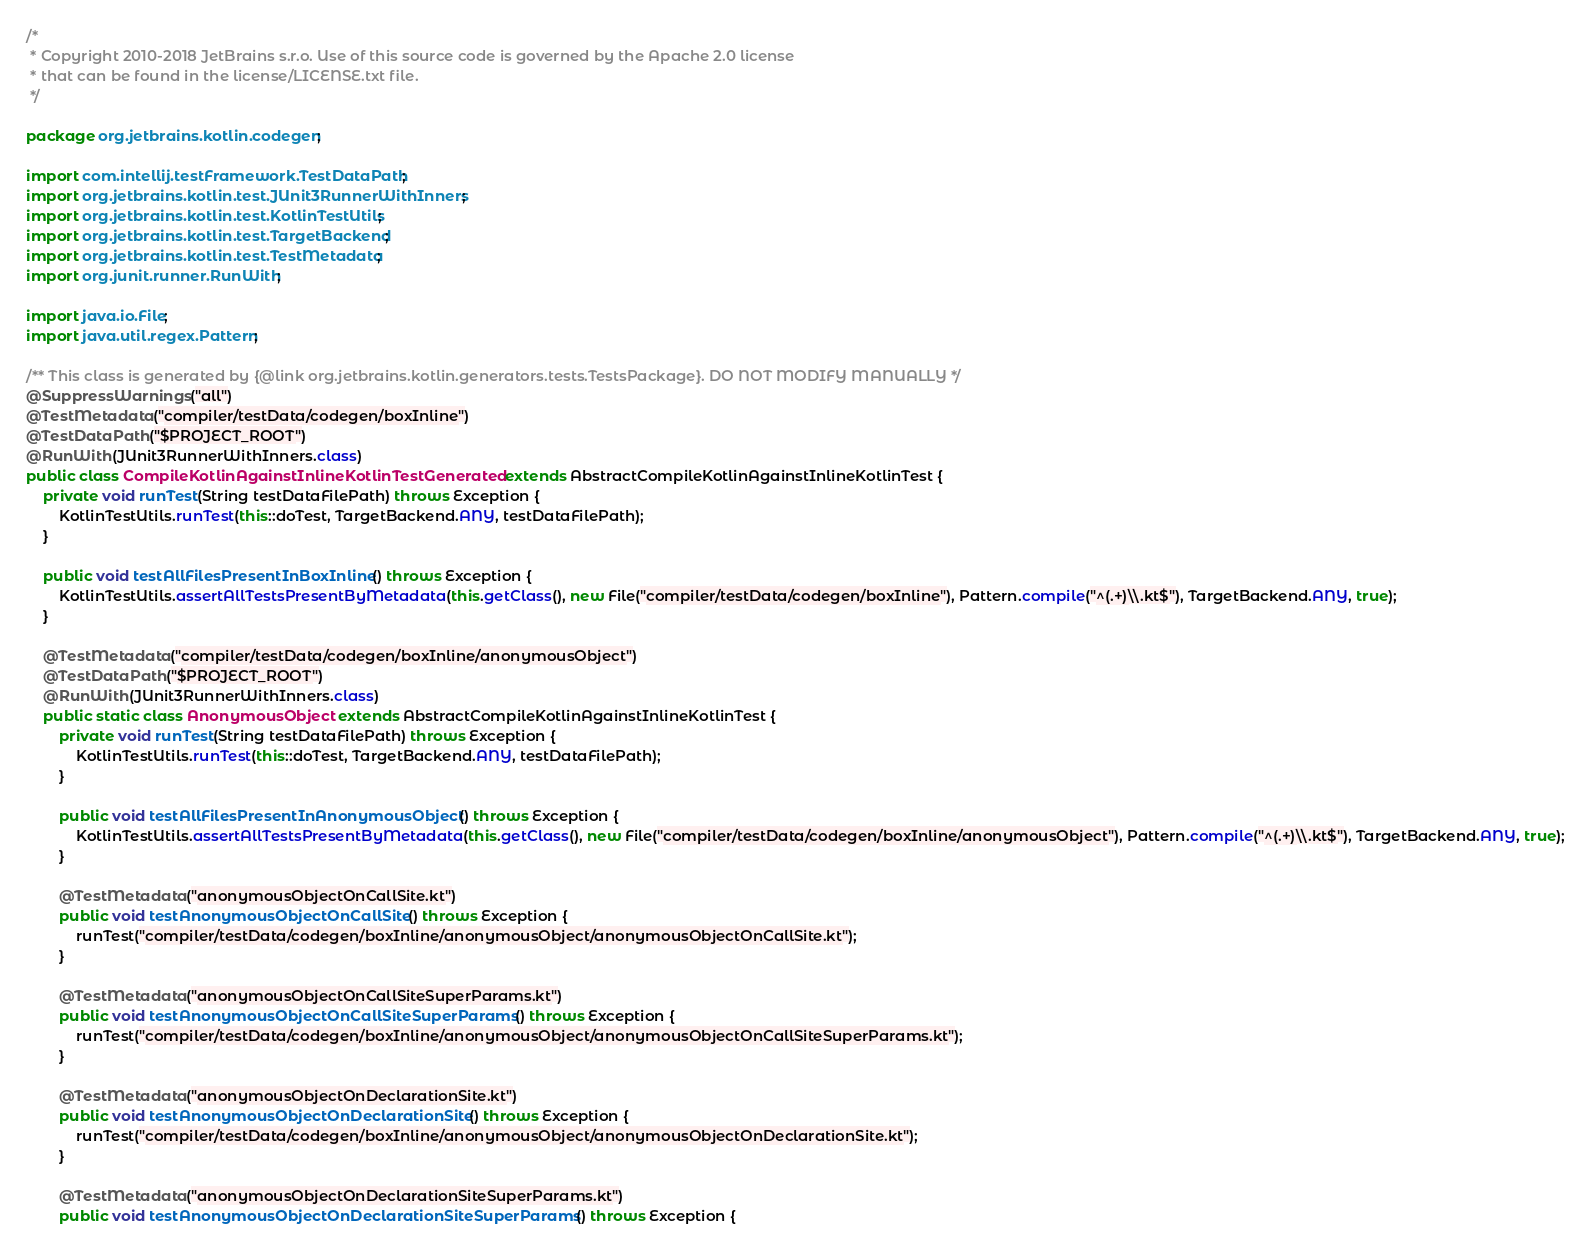Convert code to text. <code><loc_0><loc_0><loc_500><loc_500><_Java_>/*
 * Copyright 2010-2018 JetBrains s.r.o. Use of this source code is governed by the Apache 2.0 license
 * that can be found in the license/LICENSE.txt file.
 */

package org.jetbrains.kotlin.codegen;

import com.intellij.testFramework.TestDataPath;
import org.jetbrains.kotlin.test.JUnit3RunnerWithInners;
import org.jetbrains.kotlin.test.KotlinTestUtils;
import org.jetbrains.kotlin.test.TargetBackend;
import org.jetbrains.kotlin.test.TestMetadata;
import org.junit.runner.RunWith;

import java.io.File;
import java.util.regex.Pattern;

/** This class is generated by {@link org.jetbrains.kotlin.generators.tests.TestsPackage}. DO NOT MODIFY MANUALLY */
@SuppressWarnings("all")
@TestMetadata("compiler/testData/codegen/boxInline")
@TestDataPath("$PROJECT_ROOT")
@RunWith(JUnit3RunnerWithInners.class)
public class CompileKotlinAgainstInlineKotlinTestGenerated extends AbstractCompileKotlinAgainstInlineKotlinTest {
    private void runTest(String testDataFilePath) throws Exception {
        KotlinTestUtils.runTest(this::doTest, TargetBackend.ANY, testDataFilePath);
    }

    public void testAllFilesPresentInBoxInline() throws Exception {
        KotlinTestUtils.assertAllTestsPresentByMetadata(this.getClass(), new File("compiler/testData/codegen/boxInline"), Pattern.compile("^(.+)\\.kt$"), TargetBackend.ANY, true);
    }

    @TestMetadata("compiler/testData/codegen/boxInline/anonymousObject")
    @TestDataPath("$PROJECT_ROOT")
    @RunWith(JUnit3RunnerWithInners.class)
    public static class AnonymousObject extends AbstractCompileKotlinAgainstInlineKotlinTest {
        private void runTest(String testDataFilePath) throws Exception {
            KotlinTestUtils.runTest(this::doTest, TargetBackend.ANY, testDataFilePath);
        }

        public void testAllFilesPresentInAnonymousObject() throws Exception {
            KotlinTestUtils.assertAllTestsPresentByMetadata(this.getClass(), new File("compiler/testData/codegen/boxInline/anonymousObject"), Pattern.compile("^(.+)\\.kt$"), TargetBackend.ANY, true);
        }

        @TestMetadata("anonymousObjectOnCallSite.kt")
        public void testAnonymousObjectOnCallSite() throws Exception {
            runTest("compiler/testData/codegen/boxInline/anonymousObject/anonymousObjectOnCallSite.kt");
        }

        @TestMetadata("anonymousObjectOnCallSiteSuperParams.kt")
        public void testAnonymousObjectOnCallSiteSuperParams() throws Exception {
            runTest("compiler/testData/codegen/boxInline/anonymousObject/anonymousObjectOnCallSiteSuperParams.kt");
        }

        @TestMetadata("anonymousObjectOnDeclarationSite.kt")
        public void testAnonymousObjectOnDeclarationSite() throws Exception {
            runTest("compiler/testData/codegen/boxInline/anonymousObject/anonymousObjectOnDeclarationSite.kt");
        }

        @TestMetadata("anonymousObjectOnDeclarationSiteSuperParams.kt")
        public void testAnonymousObjectOnDeclarationSiteSuperParams() throws Exception {</code> 